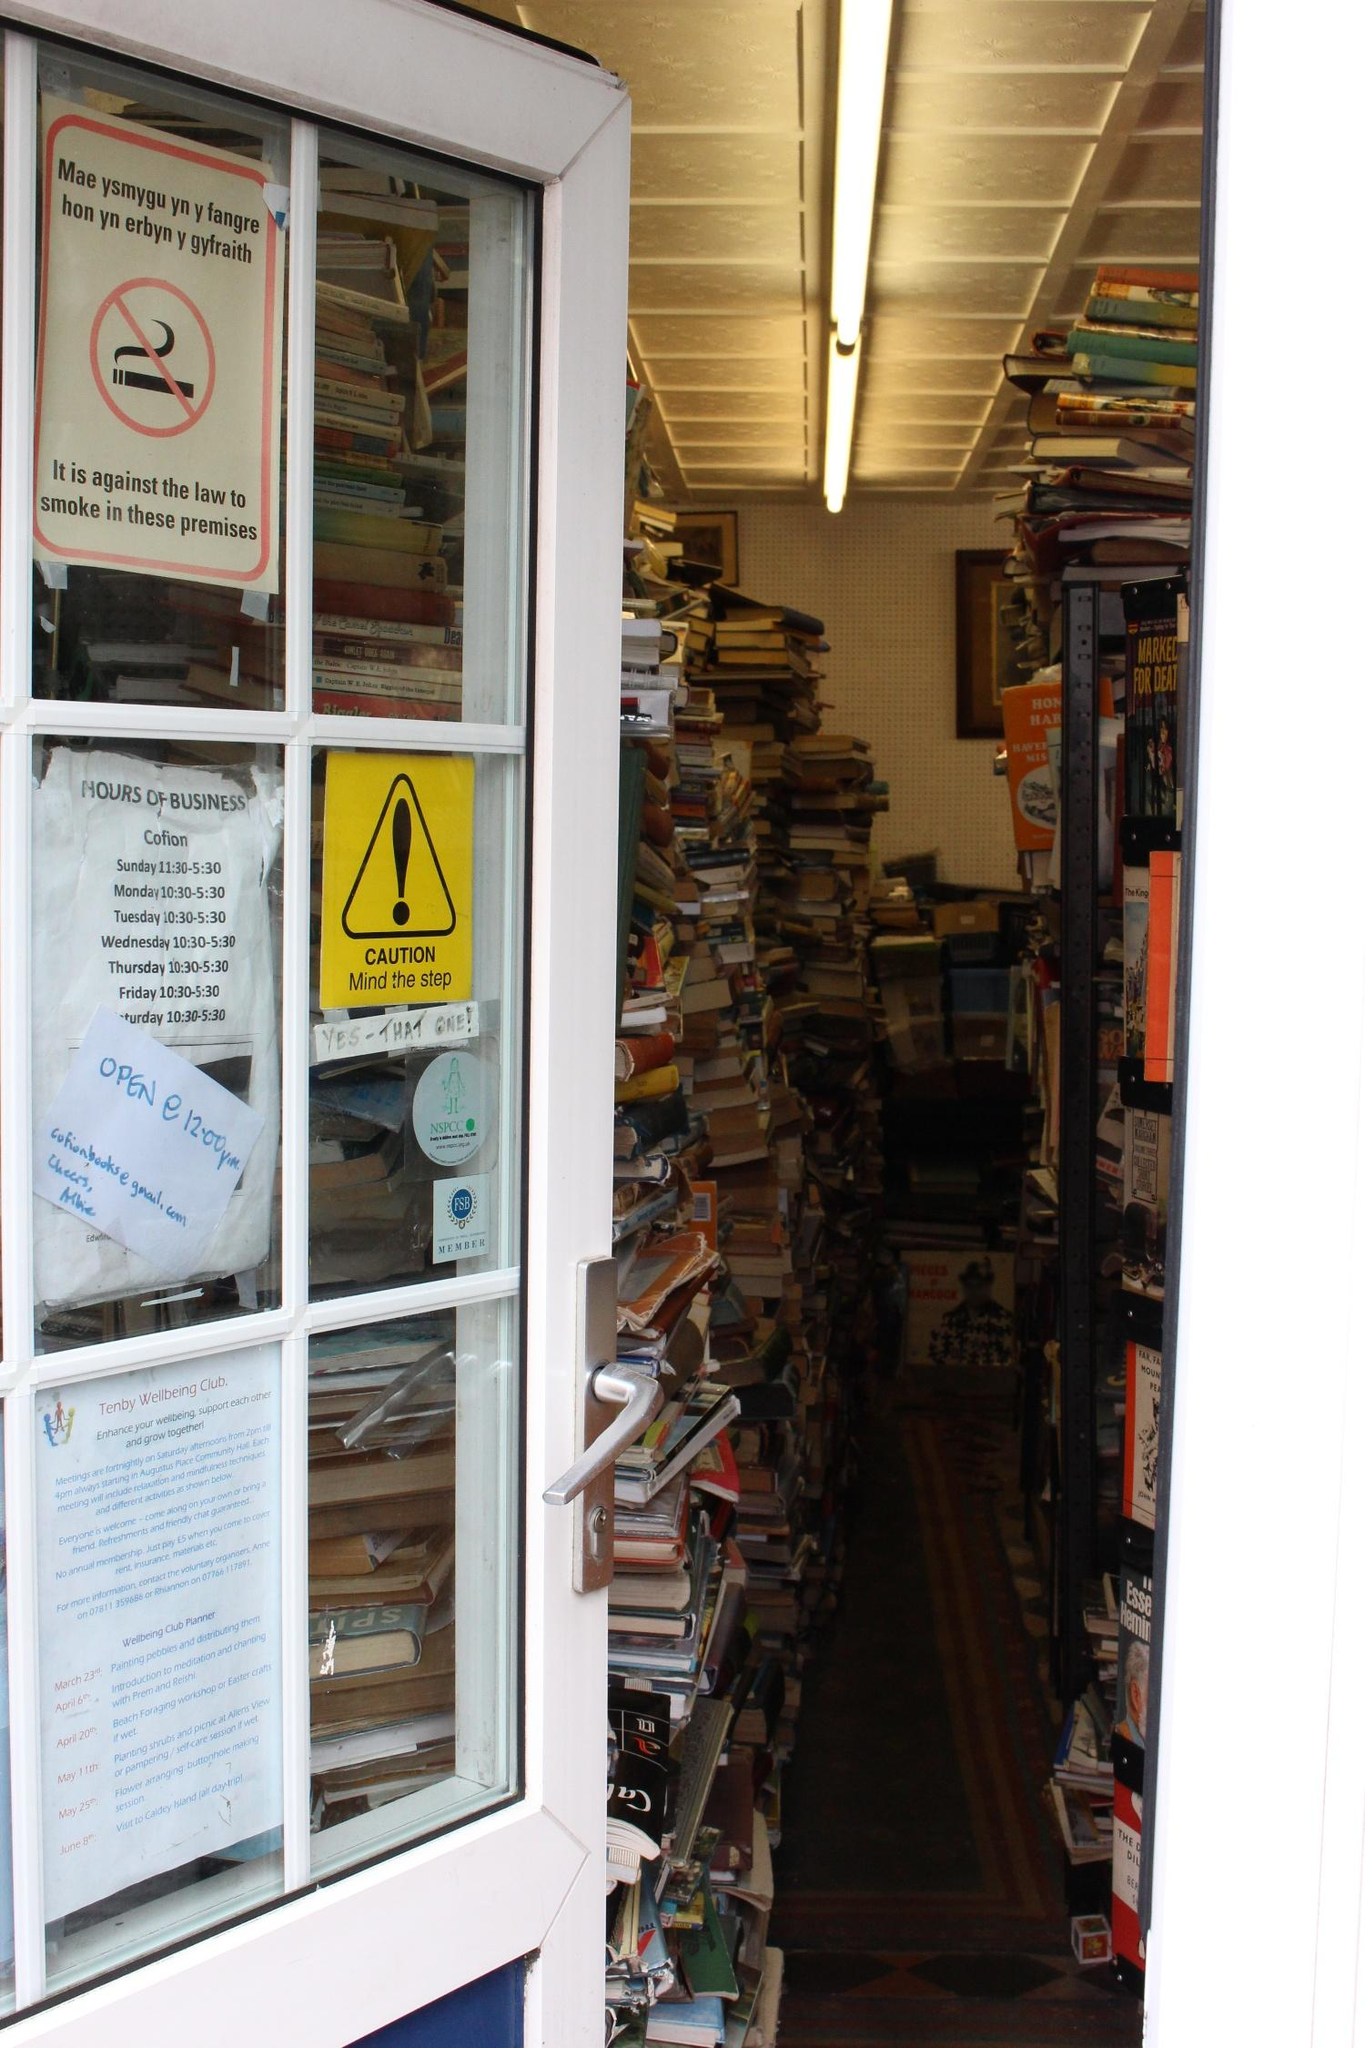Can you tell me more about the signs visible in the window? Certainly! There are several signs in the window, including a bilingual prohibition against smoking, indicating respect for health and legal considerations within the premises. Additionally, the 'CAUTION Mind the step' sign is a considerate reminder for patrons to be mindful of their footing, suggesting there might be an unexpected step or uneven flooring inside. The hours of business are clearly displayed, allowing potential customers to know when they can visit. An NSPCC certificate can also be spotted, which might imply community involvement or support for this charity. 